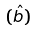<formula> <loc_0><loc_0><loc_500><loc_500>( \hat { b } )</formula> 